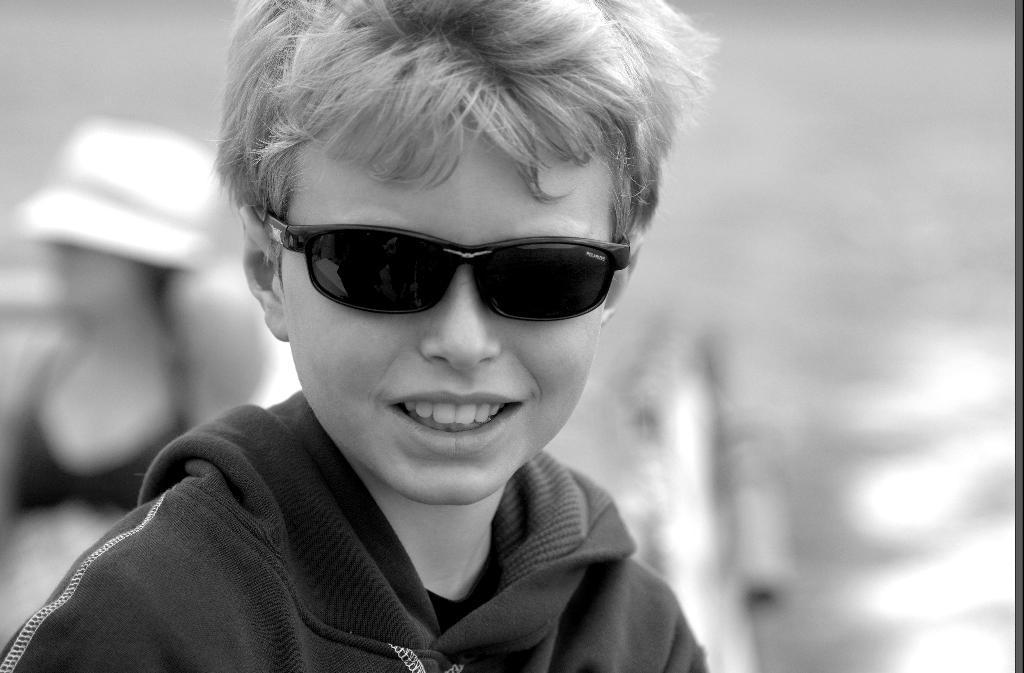How would you summarize this image in a sentence or two? This is a black and white image. In this image we can see a boy wearing spectacles. On the backside we can see a woman wearing a hat. 